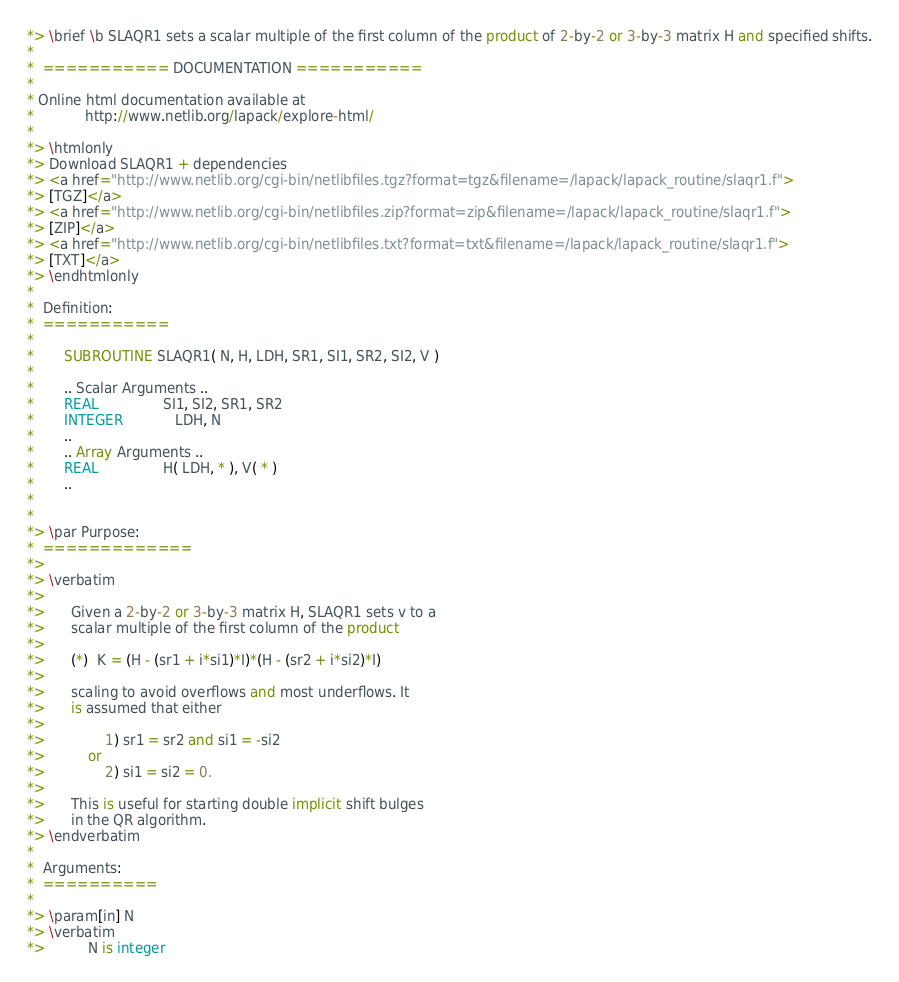Convert code to text. <code><loc_0><loc_0><loc_500><loc_500><_FORTRAN_>*> \brief \b SLAQR1 sets a scalar multiple of the first column of the product of 2-by-2 or 3-by-3 matrix H and specified shifts.
*
*  =========== DOCUMENTATION ===========
*
* Online html documentation available at 
*            http://www.netlib.org/lapack/explore-html/ 
*
*> \htmlonly
*> Download SLAQR1 + dependencies 
*> <a href="http://www.netlib.org/cgi-bin/netlibfiles.tgz?format=tgz&filename=/lapack/lapack_routine/slaqr1.f"> 
*> [TGZ]</a> 
*> <a href="http://www.netlib.org/cgi-bin/netlibfiles.zip?format=zip&filename=/lapack/lapack_routine/slaqr1.f"> 
*> [ZIP]</a> 
*> <a href="http://www.netlib.org/cgi-bin/netlibfiles.txt?format=txt&filename=/lapack/lapack_routine/slaqr1.f"> 
*> [TXT]</a>
*> \endhtmlonly 
*
*  Definition:
*  ===========
*
*       SUBROUTINE SLAQR1( N, H, LDH, SR1, SI1, SR2, SI2, V )
* 
*       .. Scalar Arguments ..
*       REAL               SI1, SI2, SR1, SR2
*       INTEGER            LDH, N
*       ..
*       .. Array Arguments ..
*       REAL               H( LDH, * ), V( * )
*       ..
*  
*
*> \par Purpose:
*  =============
*>
*> \verbatim
*>
*>      Given a 2-by-2 or 3-by-3 matrix H, SLAQR1 sets v to a
*>      scalar multiple of the first column of the product
*>
*>      (*)  K = (H - (sr1 + i*si1)*I)*(H - (sr2 + i*si2)*I)
*>
*>      scaling to avoid overflows and most underflows. It
*>      is assumed that either
*>
*>              1) sr1 = sr2 and si1 = -si2
*>          or
*>              2) si1 = si2 = 0.
*>
*>      This is useful for starting double implicit shift bulges
*>      in the QR algorithm.
*> \endverbatim
*
*  Arguments:
*  ==========
*
*> \param[in] N
*> \verbatim
*>          N is integer</code> 